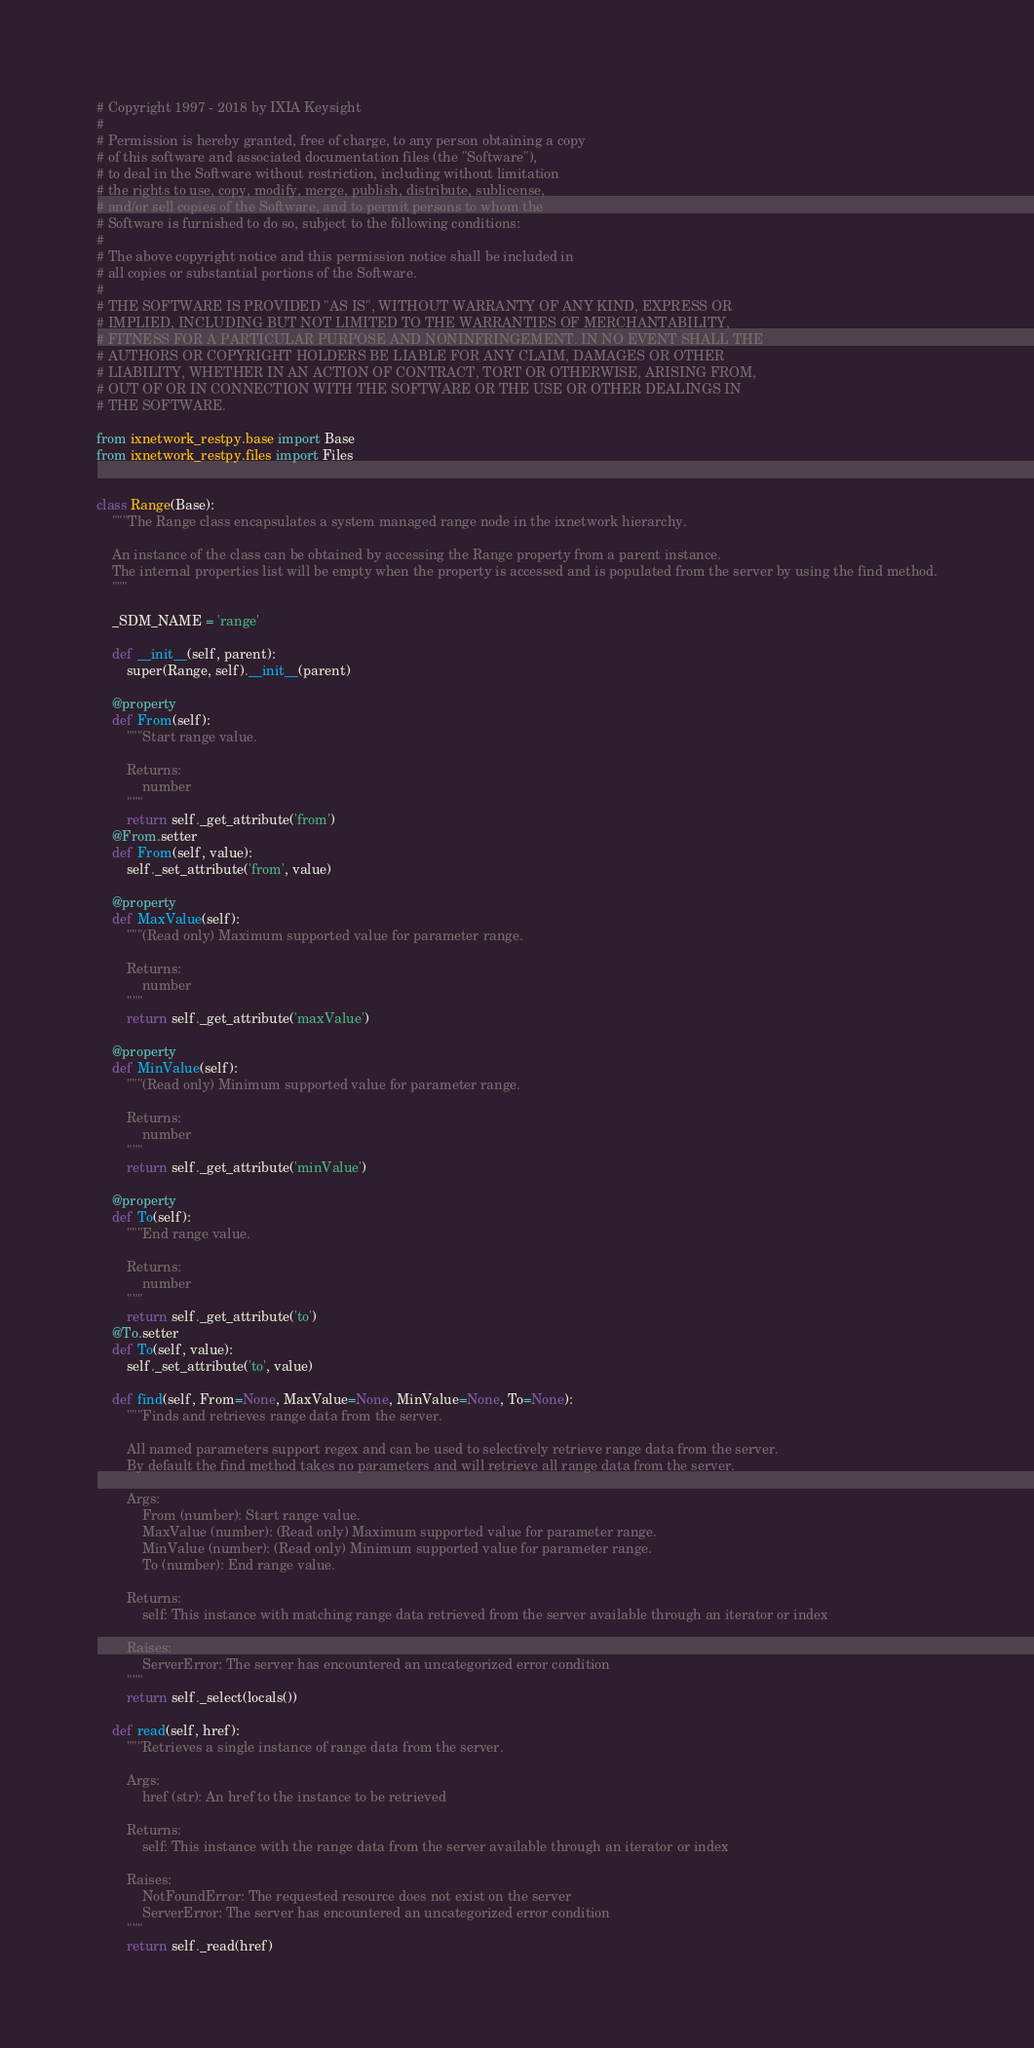<code> <loc_0><loc_0><loc_500><loc_500><_Python_>
# Copyright 1997 - 2018 by IXIA Keysight
#
# Permission is hereby granted, free of charge, to any person obtaining a copy
# of this software and associated documentation files (the "Software"),
# to deal in the Software without restriction, including without limitation
# the rights to use, copy, modify, merge, publish, distribute, sublicense,
# and/or sell copies of the Software, and to permit persons to whom the
# Software is furnished to do so, subject to the following conditions:
#
# The above copyright notice and this permission notice shall be included in
# all copies or substantial portions of the Software.
#
# THE SOFTWARE IS PROVIDED "AS IS", WITHOUT WARRANTY OF ANY KIND, EXPRESS OR
# IMPLIED, INCLUDING BUT NOT LIMITED TO THE WARRANTIES OF MERCHANTABILITY,
# FITNESS FOR A PARTICULAR PURPOSE AND NONINFRINGEMENT. IN NO EVENT SHALL THE
# AUTHORS OR COPYRIGHT HOLDERS BE LIABLE FOR ANY CLAIM, DAMAGES OR OTHER
# LIABILITY, WHETHER IN AN ACTION OF CONTRACT, TORT OR OTHERWISE, ARISING FROM,
# OUT OF OR IN CONNECTION WITH THE SOFTWARE OR THE USE OR OTHER DEALINGS IN
# THE SOFTWARE.
    
from ixnetwork_restpy.base import Base
from ixnetwork_restpy.files import Files


class Range(Base):
	"""The Range class encapsulates a system managed range node in the ixnetwork hierarchy.

	An instance of the class can be obtained by accessing the Range property from a parent instance.
	The internal properties list will be empty when the property is accessed and is populated from the server by using the find method.
	"""

	_SDM_NAME = 'range'

	def __init__(self, parent):
		super(Range, self).__init__(parent)

	@property
	def From(self):
		"""Start range value.

		Returns:
			number
		"""
		return self._get_attribute('from')
	@From.setter
	def From(self, value):
		self._set_attribute('from', value)

	@property
	def MaxValue(self):
		"""(Read only) Maximum supported value for parameter range.

		Returns:
			number
		"""
		return self._get_attribute('maxValue')

	@property
	def MinValue(self):
		"""(Read only) Minimum supported value for parameter range.

		Returns:
			number
		"""
		return self._get_attribute('minValue')

	@property
	def To(self):
		"""End range value.

		Returns:
			number
		"""
		return self._get_attribute('to')
	@To.setter
	def To(self, value):
		self._set_attribute('to', value)

	def find(self, From=None, MaxValue=None, MinValue=None, To=None):
		"""Finds and retrieves range data from the server.

		All named parameters support regex and can be used to selectively retrieve range data from the server.
		By default the find method takes no parameters and will retrieve all range data from the server.

		Args:
			From (number): Start range value.
			MaxValue (number): (Read only) Maximum supported value for parameter range.
			MinValue (number): (Read only) Minimum supported value for parameter range.
			To (number): End range value.

		Returns:
			self: This instance with matching range data retrieved from the server available through an iterator or index

		Raises:
			ServerError: The server has encountered an uncategorized error condition
		"""
		return self._select(locals())

	def read(self, href):
		"""Retrieves a single instance of range data from the server.

		Args:
			href (str): An href to the instance to be retrieved

		Returns:
			self: This instance with the range data from the server available through an iterator or index

		Raises:
			NotFoundError: The requested resource does not exist on the server
			ServerError: The server has encountered an uncategorized error condition
		"""
		return self._read(href)
</code> 